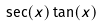Convert formula to latex. <formula><loc_0><loc_0><loc_500><loc_500>\sec ( x ) \tan ( x )</formula> 